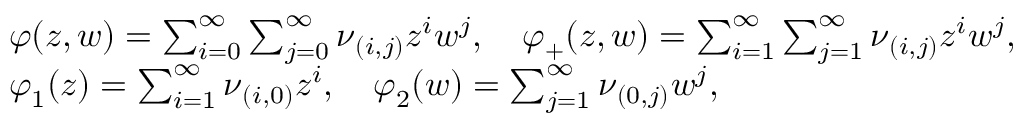Convert formula to latex. <formula><loc_0><loc_0><loc_500><loc_500>\begin{array} { r l } & { \varphi ( z , w ) = \sum _ { i = 0 } ^ { \infty } \sum _ { j = 0 } ^ { \infty } \nu _ { ( i , j ) } z ^ { i } w ^ { j } , \quad \varphi _ { + } ( z , w ) = \sum _ { i = 1 } ^ { \infty } \sum _ { j = 1 } ^ { \infty } \nu _ { ( i , j ) } z ^ { i } w ^ { j } , } \\ & { \varphi _ { 1 } ( z ) = \sum _ { i = 1 } ^ { \infty } \nu _ { ( i , 0 ) } z ^ { i } , \quad \varphi _ { 2 } ( w ) = \sum _ { j = 1 } ^ { \infty } \nu _ { ( 0 , j ) } w ^ { j } , } \end{array}</formula> 